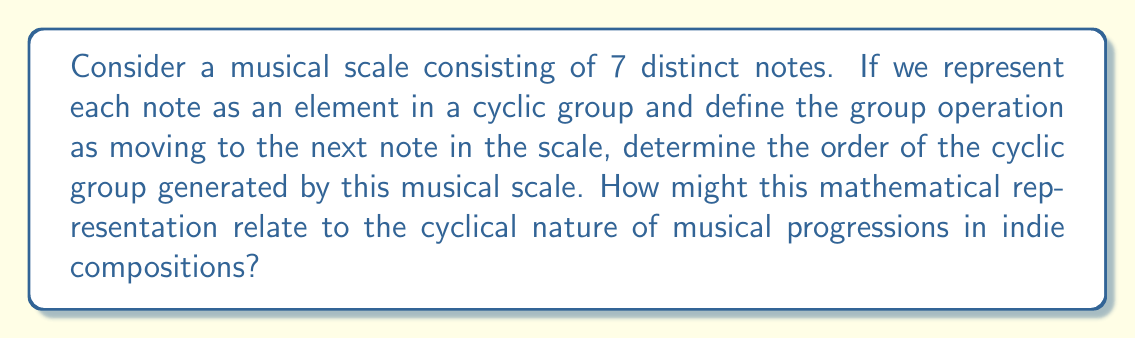Could you help me with this problem? Let's approach this step-by-step:

1) In group theory, a cyclic group is a group that can be generated by a single element. In this case, our generator is the musical scale itself.

2) The order of a cyclic group is the number of unique elements in the group before it repeats.

3) In our musical scale:
   - We have 7 distinct notes
   - The group operation moves us to the next note
   - After the 7th note, we return to the 1st note

4) Mathematically, we can represent this as:

   $$\langle a \rangle = \{a^1, a^2, a^3, a^4, a^5, a^6, a^7\}$$

   where $a$ represents the generator (our scale) and the exponents represent the number of times we apply the group operation.

5) We can see that $a^8 = a^1$, as we've returned to our starting point.

6) Therefore, the order of this cyclic group is 7.

This mathematical representation relates to indie compositions in several ways:
- It reflects the cyclical nature of musical progressions, where composers often return to the root note.
- It emphasizes the importance of each note in the scale, mirroring how indie artists often use minimalistic arrangements to highlight individual elements.
- The finite order of the group (7) could represent the constraints within which artists create, turning limitations into artistic expressions.
Answer: The order of the cyclic group generated by the 7-note musical scale is 7. 